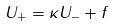<formula> <loc_0><loc_0><loc_500><loc_500>U _ { + } = \kappa U _ { - } + f</formula> 